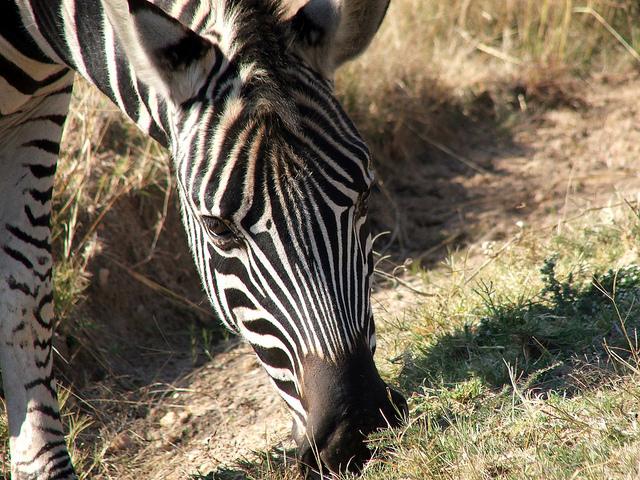What is eating grass?
Quick response, please. Zebra. Is it daytime?
Quick response, please. Yes. Do you see stripes or solids?
Concise answer only. Stripes. 